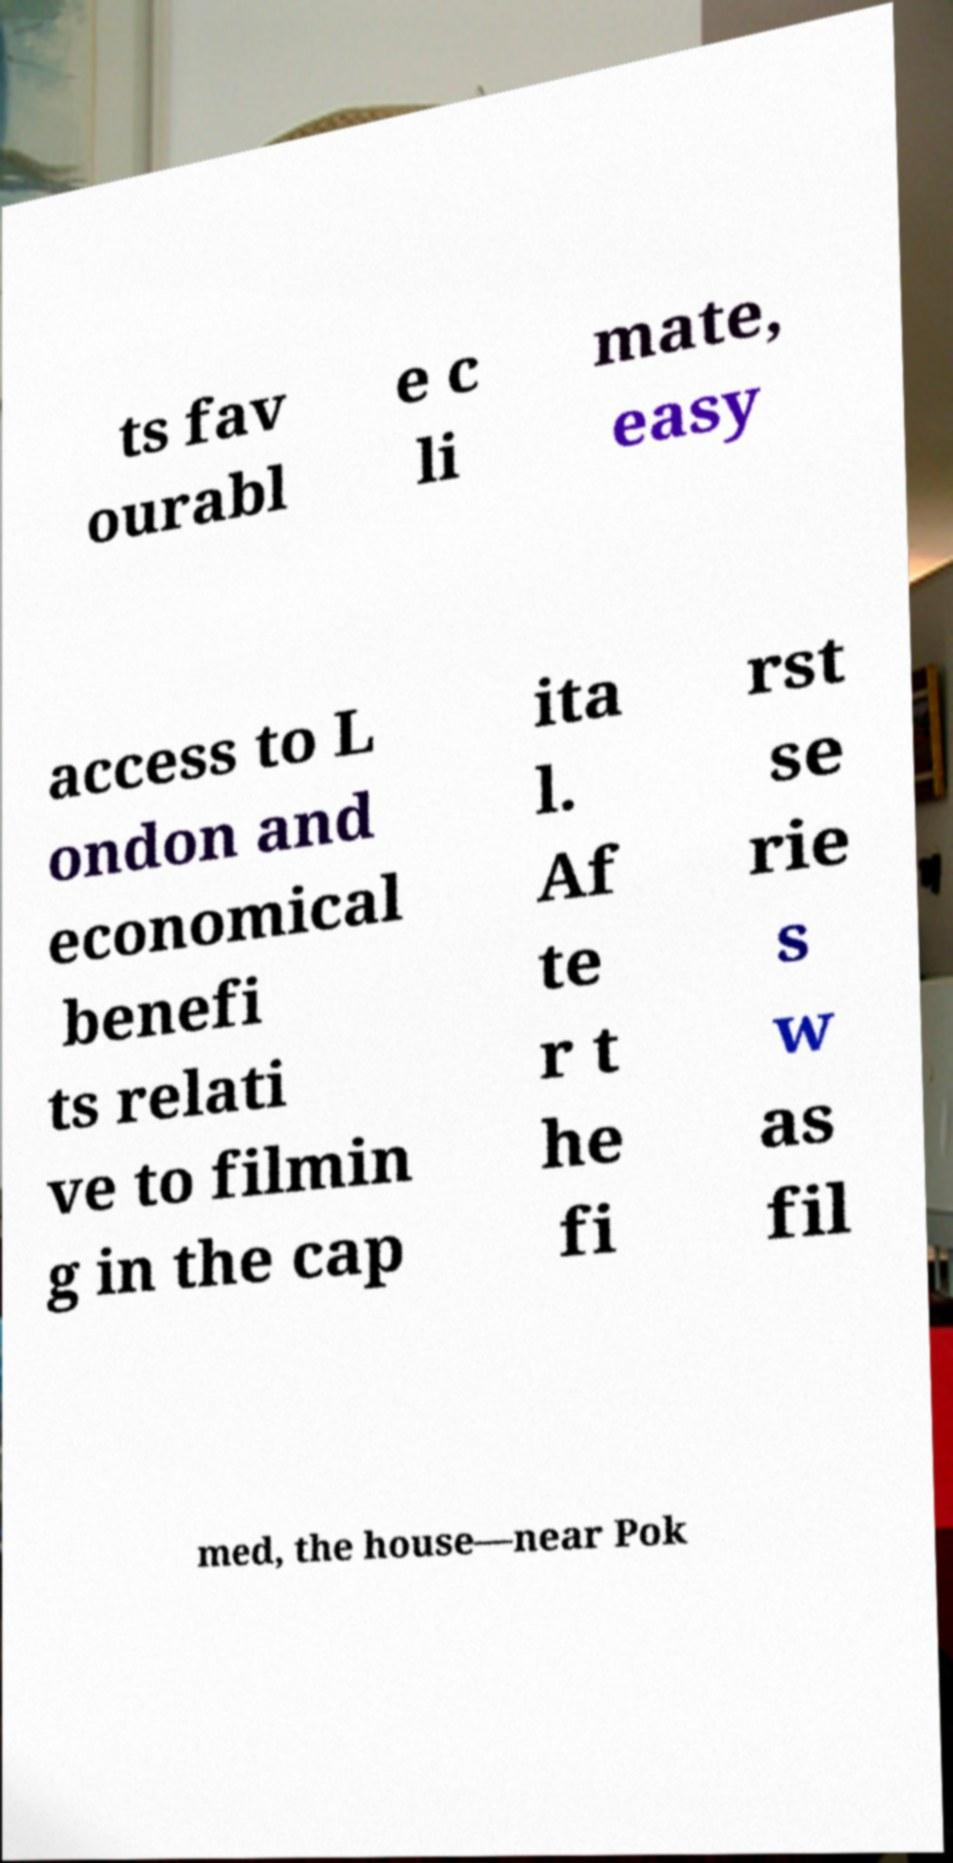What messages or text are displayed in this image? I need them in a readable, typed format. ts fav ourabl e c li mate, easy access to L ondon and economical benefi ts relati ve to filmin g in the cap ita l. Af te r t he fi rst se rie s w as fil med, the house—near Pok 